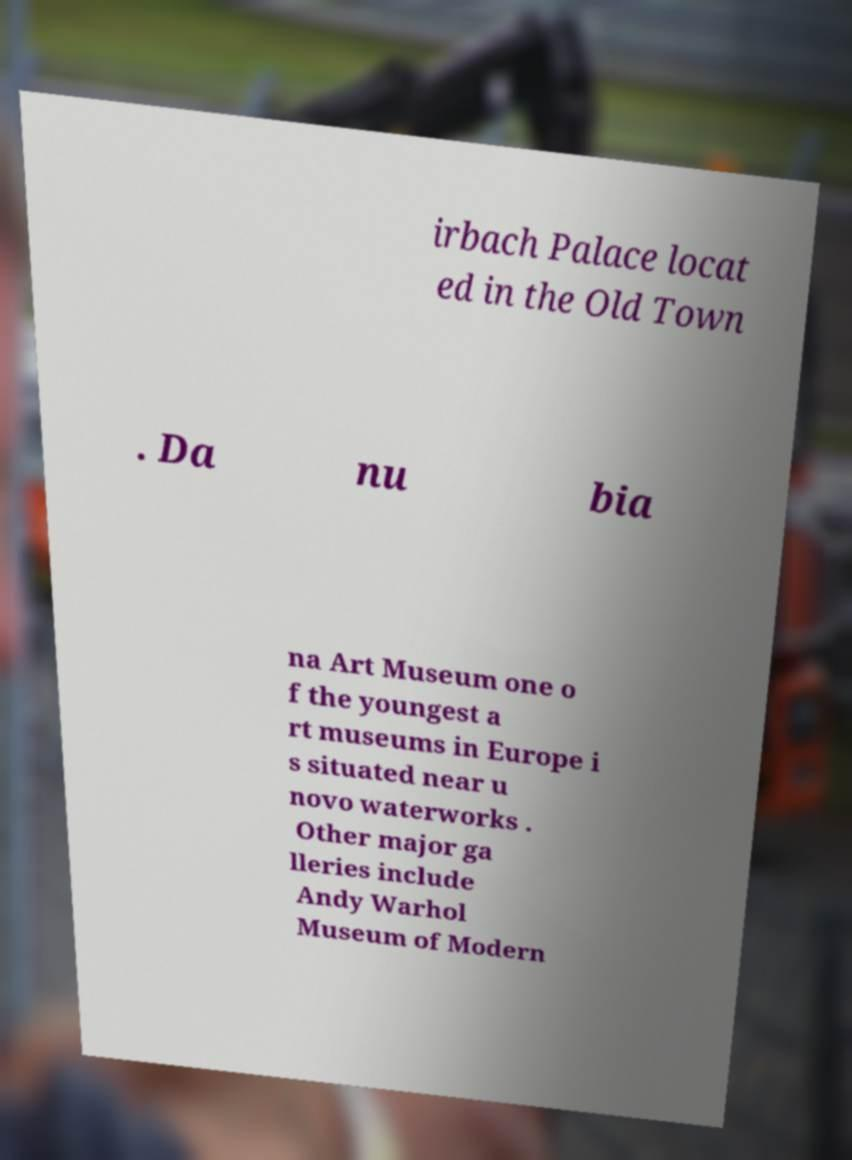Please identify and transcribe the text found in this image. irbach Palace locat ed in the Old Town . Da nu bia na Art Museum one o f the youngest a rt museums in Europe i s situated near u novo waterworks . Other major ga lleries include Andy Warhol Museum of Modern 